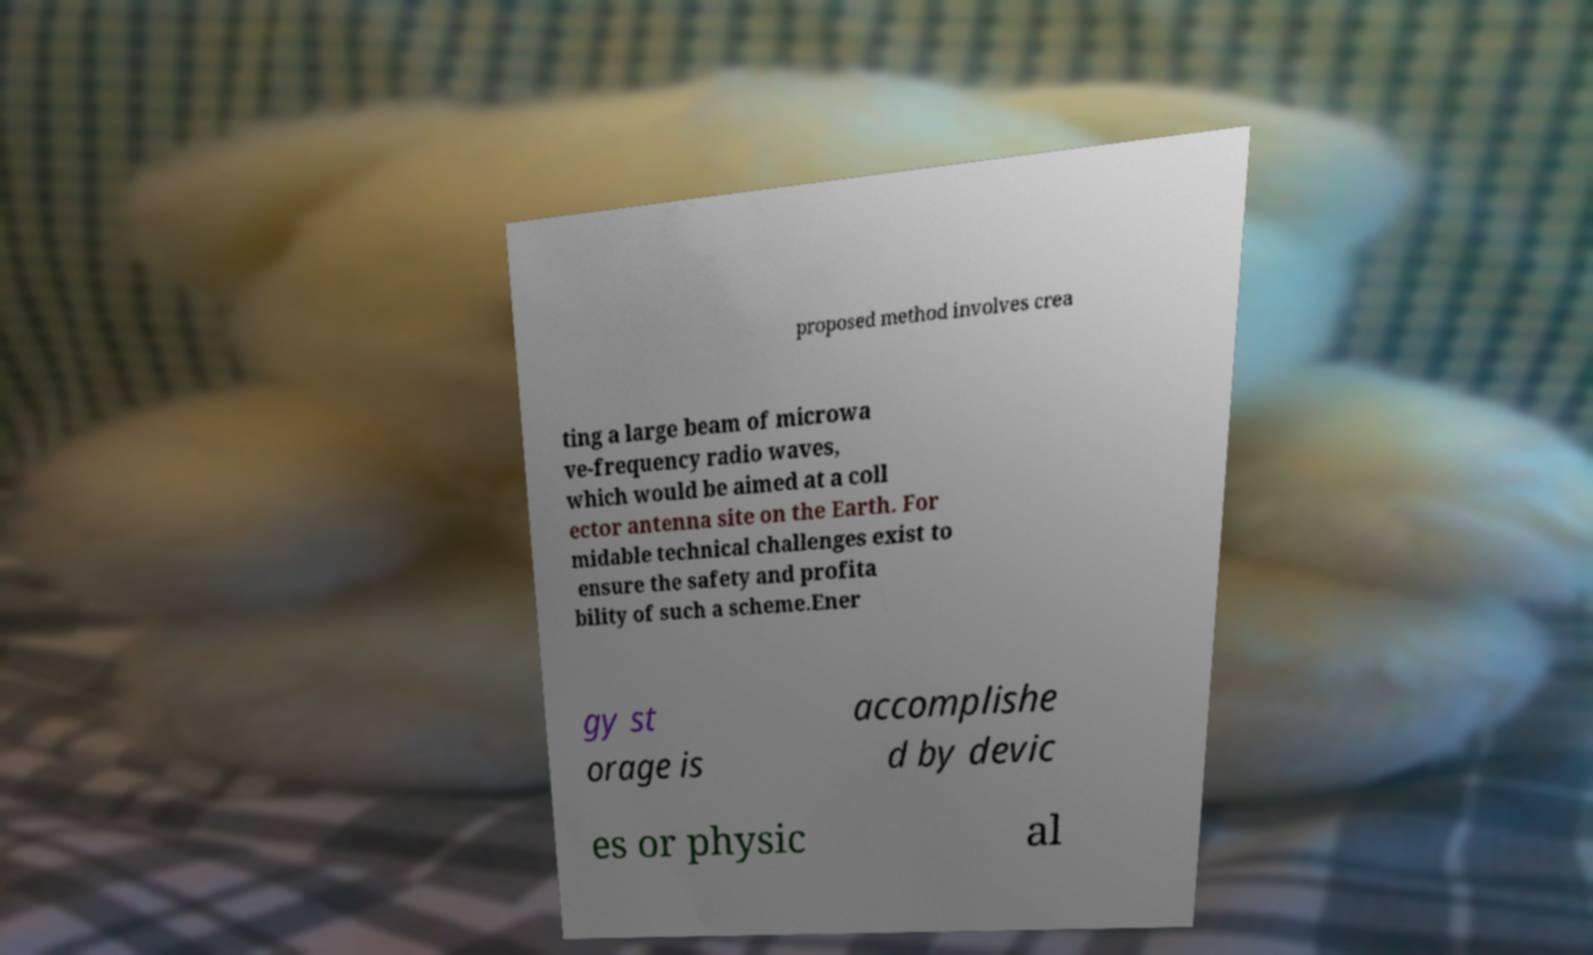Can you accurately transcribe the text from the provided image for me? proposed method involves crea ting a large beam of microwa ve-frequency radio waves, which would be aimed at a coll ector antenna site on the Earth. For midable technical challenges exist to ensure the safety and profita bility of such a scheme.Ener gy st orage is accomplishe d by devic es or physic al 